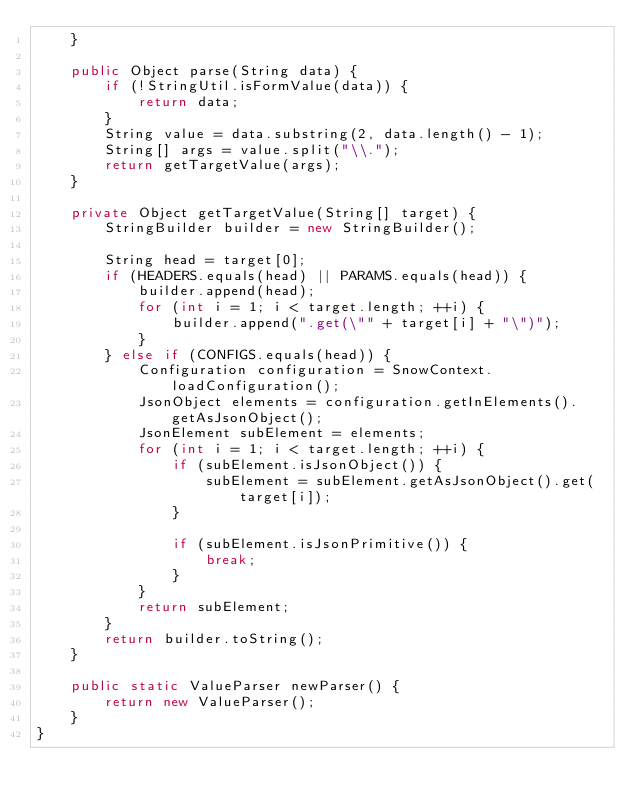<code> <loc_0><loc_0><loc_500><loc_500><_Java_>    }

    public Object parse(String data) {
        if (!StringUtil.isFormValue(data)) {
            return data;
        }
        String value = data.substring(2, data.length() - 1);
        String[] args = value.split("\\.");
        return getTargetValue(args);
    }

    private Object getTargetValue(String[] target) {
        StringBuilder builder = new StringBuilder();

        String head = target[0];
        if (HEADERS.equals(head) || PARAMS.equals(head)) {
            builder.append(head);
            for (int i = 1; i < target.length; ++i) {
                builder.append(".get(\"" + target[i] + "\")");
            }
        } else if (CONFIGS.equals(head)) {
            Configuration configuration = SnowContext.loadConfiguration();
            JsonObject elements = configuration.getInElements().getAsJsonObject();
            JsonElement subElement = elements;
            for (int i = 1; i < target.length; ++i) {
                if (subElement.isJsonObject()) {
                    subElement = subElement.getAsJsonObject().get(target[i]);
                }

                if (subElement.isJsonPrimitive()) {
                    break;
                }
            }
            return subElement;
        }
        return builder.toString();
    }

    public static ValueParser newParser() {
        return new ValueParser();
    }
}
</code> 